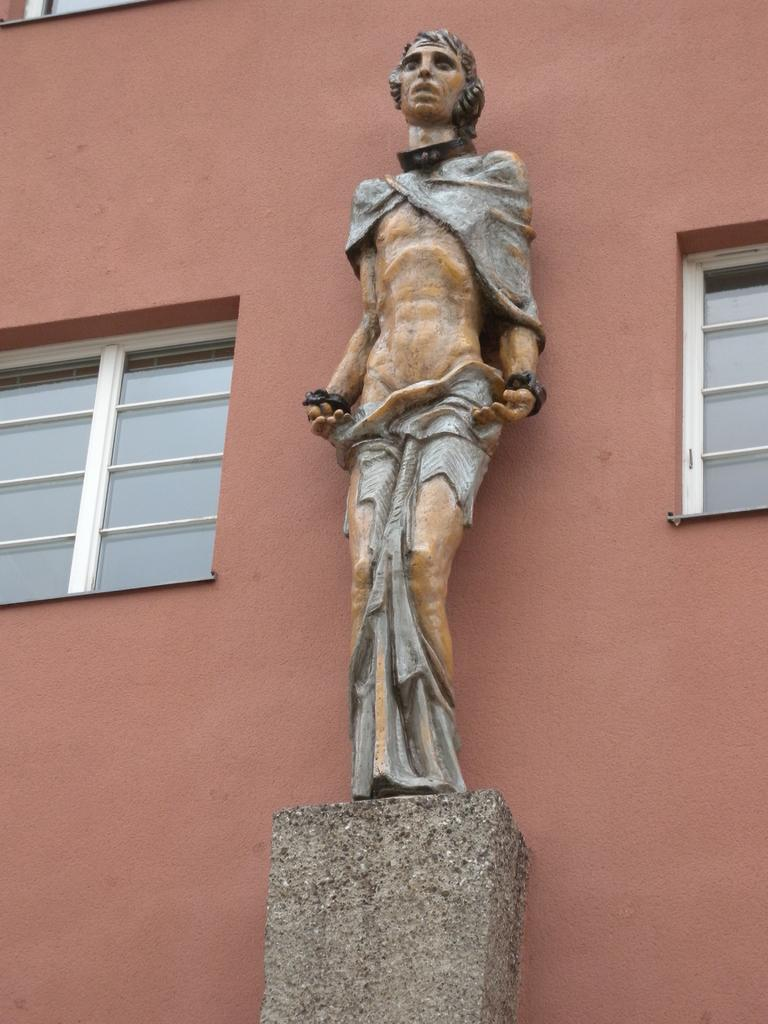What is the main subject of the image? There is a sculpture on a stone in the image. What else can be seen in the image? There is a wall and windows in the image. How many cows are visible in the image? There are no cows present in the image. What type of butter is being used to create the sculpture in the image? There is no butter involved in the creation of the sculpture in the image. 